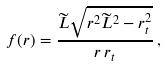<formula> <loc_0><loc_0><loc_500><loc_500>f ( r ) = \frac { \widetilde { L } \sqrt { r ^ { 2 } \widetilde { L } ^ { 2 } - r _ { t } ^ { 2 } } } { r \, r _ { t } } \, ,</formula> 